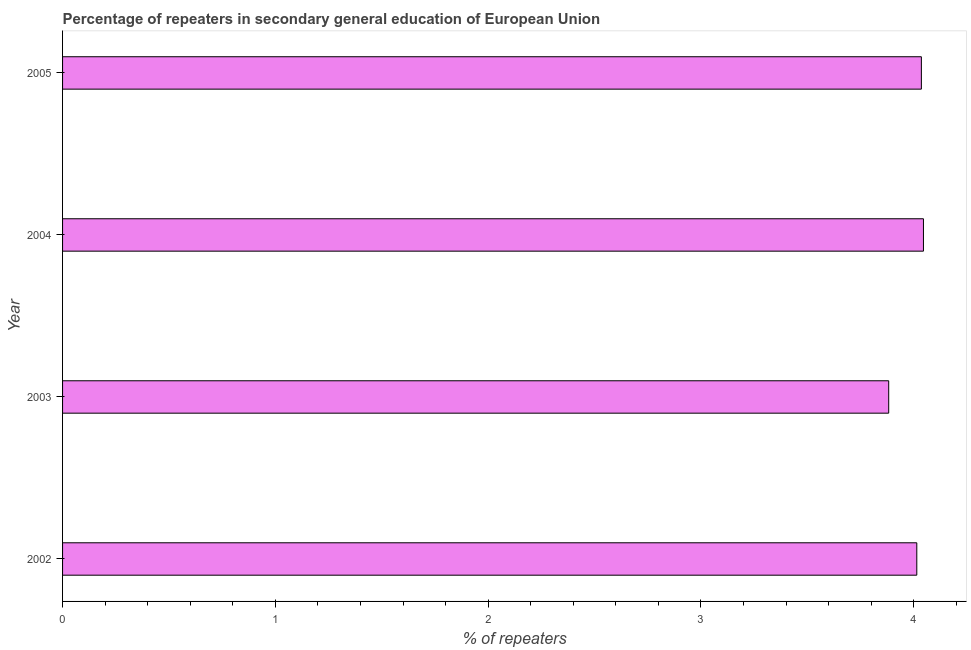Does the graph contain any zero values?
Ensure brevity in your answer.  No. Does the graph contain grids?
Offer a very short reply. No. What is the title of the graph?
Make the answer very short. Percentage of repeaters in secondary general education of European Union. What is the label or title of the X-axis?
Ensure brevity in your answer.  % of repeaters. What is the percentage of repeaters in 2004?
Make the answer very short. 4.05. Across all years, what is the maximum percentage of repeaters?
Your answer should be very brief. 4.05. Across all years, what is the minimum percentage of repeaters?
Give a very brief answer. 3.88. What is the sum of the percentage of repeaters?
Ensure brevity in your answer.  15.98. What is the average percentage of repeaters per year?
Give a very brief answer. 4. What is the median percentage of repeaters?
Your answer should be very brief. 4.03. In how many years, is the percentage of repeaters greater than 3.4 %?
Give a very brief answer. 4. What is the ratio of the percentage of repeaters in 2004 to that in 2005?
Keep it short and to the point. 1. What is the difference between the highest and the second highest percentage of repeaters?
Offer a very short reply. 0.01. Is the sum of the percentage of repeaters in 2003 and 2005 greater than the maximum percentage of repeaters across all years?
Make the answer very short. Yes. What is the difference between the highest and the lowest percentage of repeaters?
Provide a short and direct response. 0.16. How many bars are there?
Provide a succinct answer. 4. How many years are there in the graph?
Keep it short and to the point. 4. What is the difference between two consecutive major ticks on the X-axis?
Make the answer very short. 1. What is the % of repeaters in 2002?
Make the answer very short. 4.01. What is the % of repeaters in 2003?
Offer a very short reply. 3.88. What is the % of repeaters in 2004?
Provide a short and direct response. 4.05. What is the % of repeaters in 2005?
Offer a terse response. 4.04. What is the difference between the % of repeaters in 2002 and 2003?
Your answer should be compact. 0.13. What is the difference between the % of repeaters in 2002 and 2004?
Ensure brevity in your answer.  -0.03. What is the difference between the % of repeaters in 2002 and 2005?
Keep it short and to the point. -0.02. What is the difference between the % of repeaters in 2003 and 2004?
Provide a succinct answer. -0.16. What is the difference between the % of repeaters in 2003 and 2005?
Provide a short and direct response. -0.15. What is the difference between the % of repeaters in 2004 and 2005?
Keep it short and to the point. 0.01. What is the ratio of the % of repeaters in 2002 to that in 2003?
Your response must be concise. 1.03. What is the ratio of the % of repeaters in 2002 to that in 2005?
Your answer should be very brief. 0.99. What is the ratio of the % of repeaters in 2003 to that in 2004?
Keep it short and to the point. 0.96. 